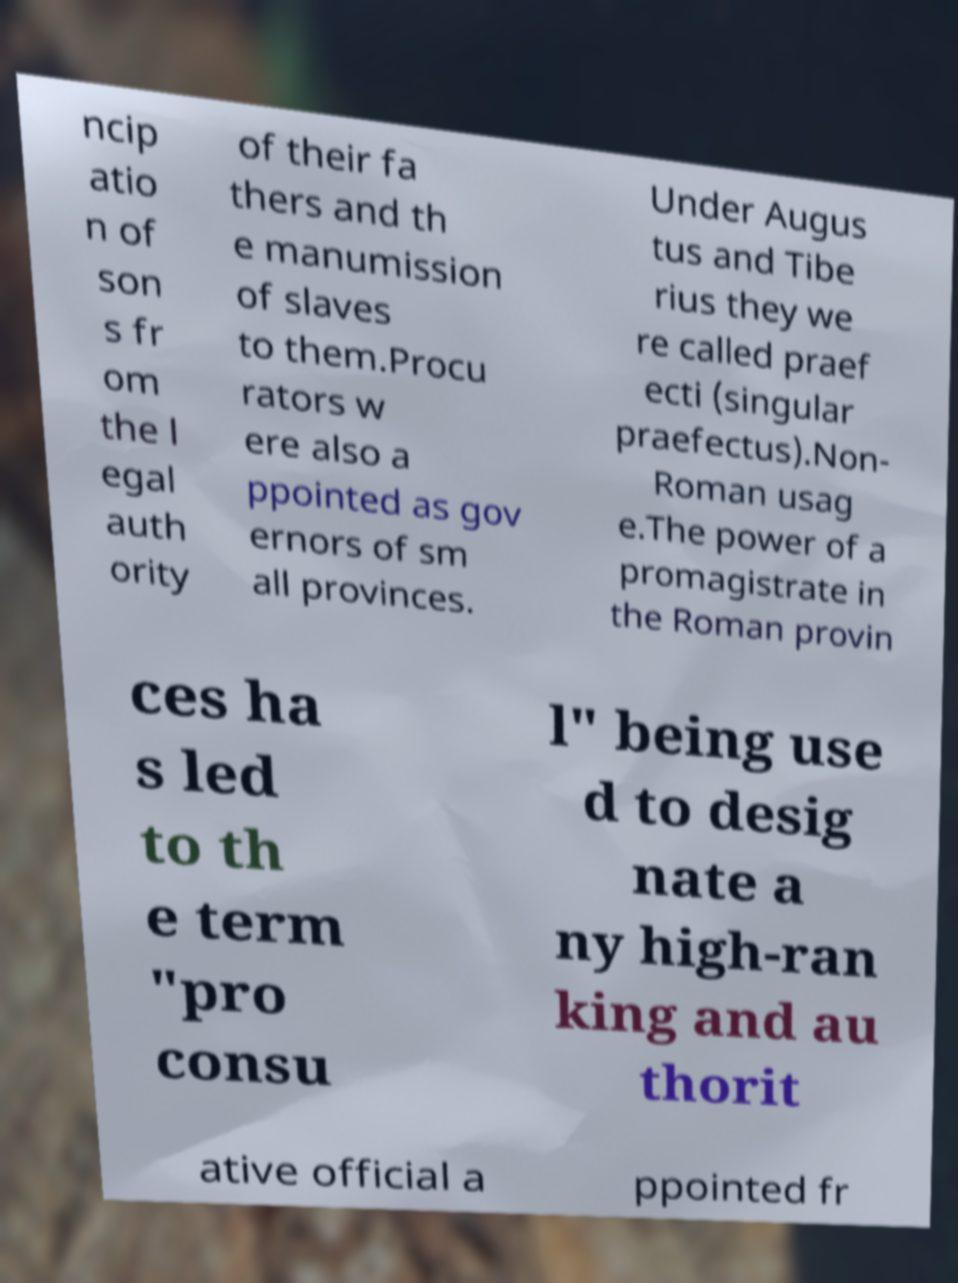Please read and relay the text visible in this image. What does it say? ncip atio n of son s fr om the l egal auth ority of their fa thers and th e manumission of slaves to them.Procu rators w ere also a ppointed as gov ernors of sm all provinces. Under Augus tus and Tibe rius they we re called praef ecti (singular praefectus).Non- Roman usag e.The power of a promagistrate in the Roman provin ces ha s led to th e term "pro consu l" being use d to desig nate a ny high-ran king and au thorit ative official a ppointed fr 